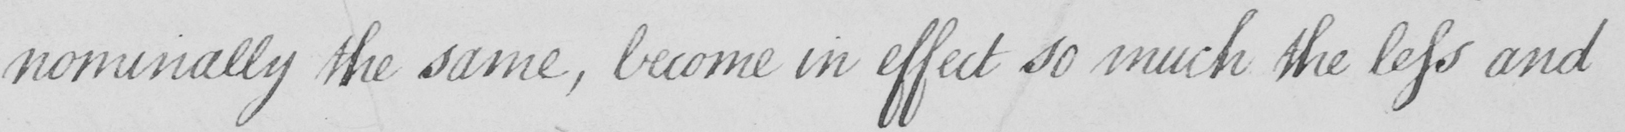Please transcribe the handwritten text in this image. nominally the same , become in effect so much the less and 